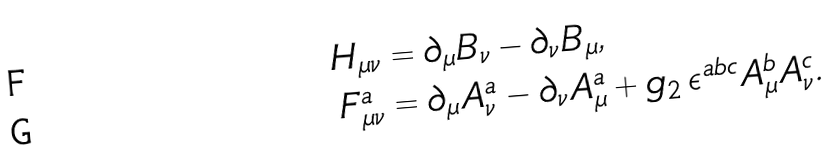<formula> <loc_0><loc_0><loc_500><loc_500>H _ { \mu \nu } & = \partial _ { \mu } B _ { \nu } - \partial _ { \nu } B _ { \mu } , \\ F ^ { a } _ { \mu \nu } & = \partial _ { \mu } A ^ { a } _ { \nu } - \partial _ { \nu } A ^ { a } _ { \mu } + g _ { 2 } \, \epsilon ^ { a b c } A ^ { b } _ { \mu } A ^ { c } _ { \nu } .</formula> 